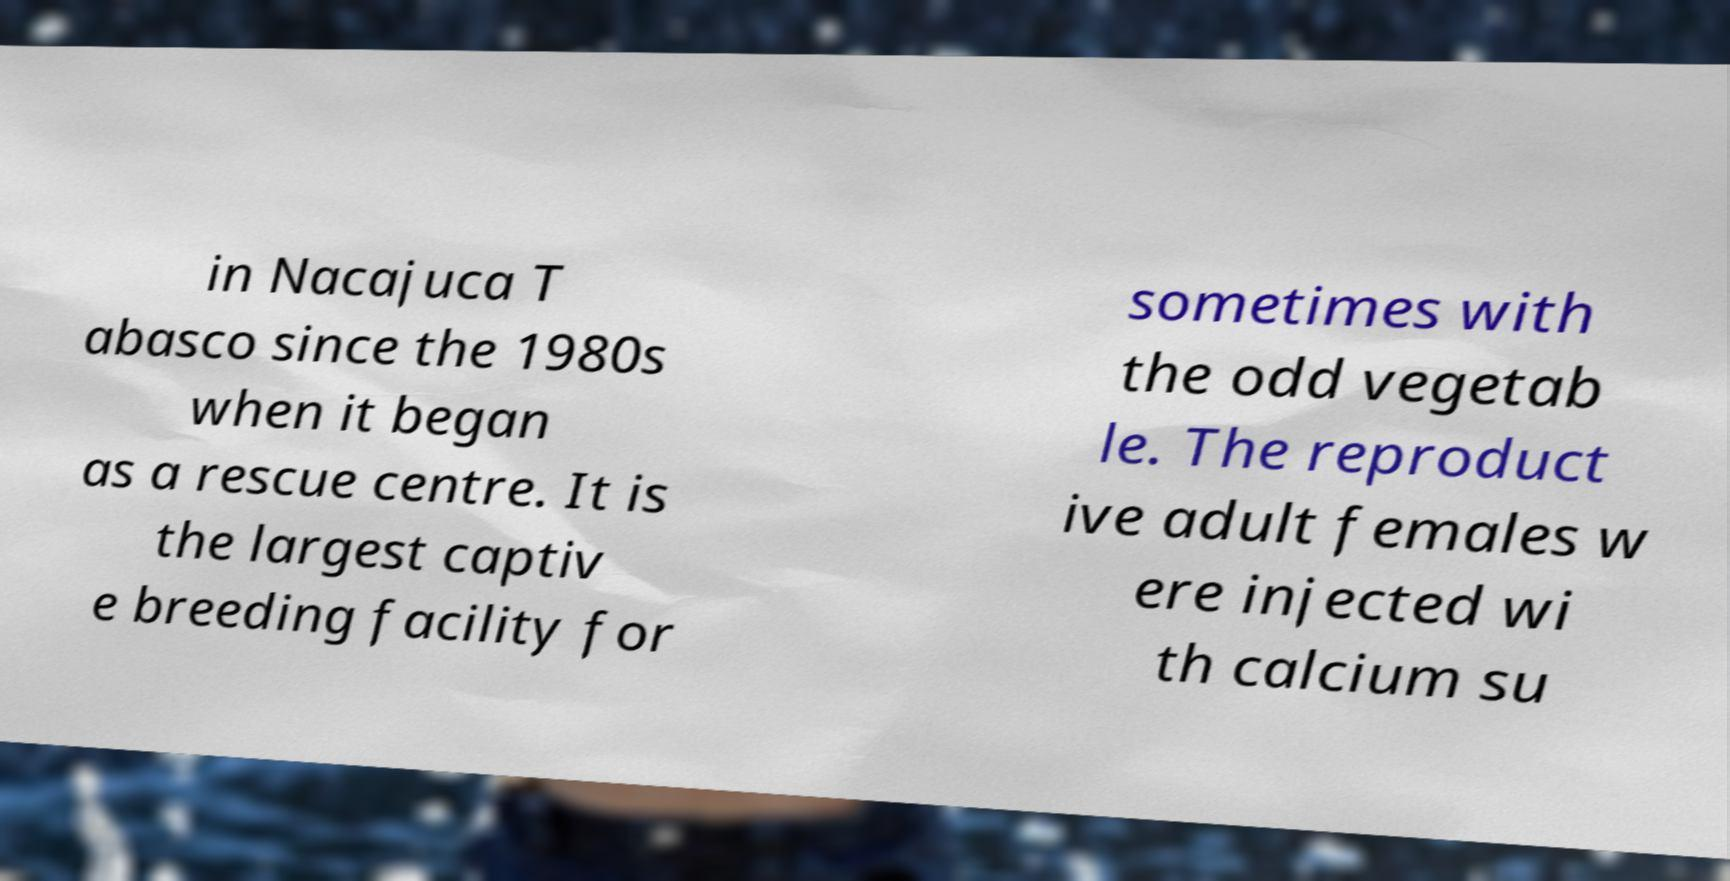Could you assist in decoding the text presented in this image and type it out clearly? in Nacajuca T abasco since the 1980s when it began as a rescue centre. It is the largest captiv e breeding facility for sometimes with the odd vegetab le. The reproduct ive adult females w ere injected wi th calcium su 